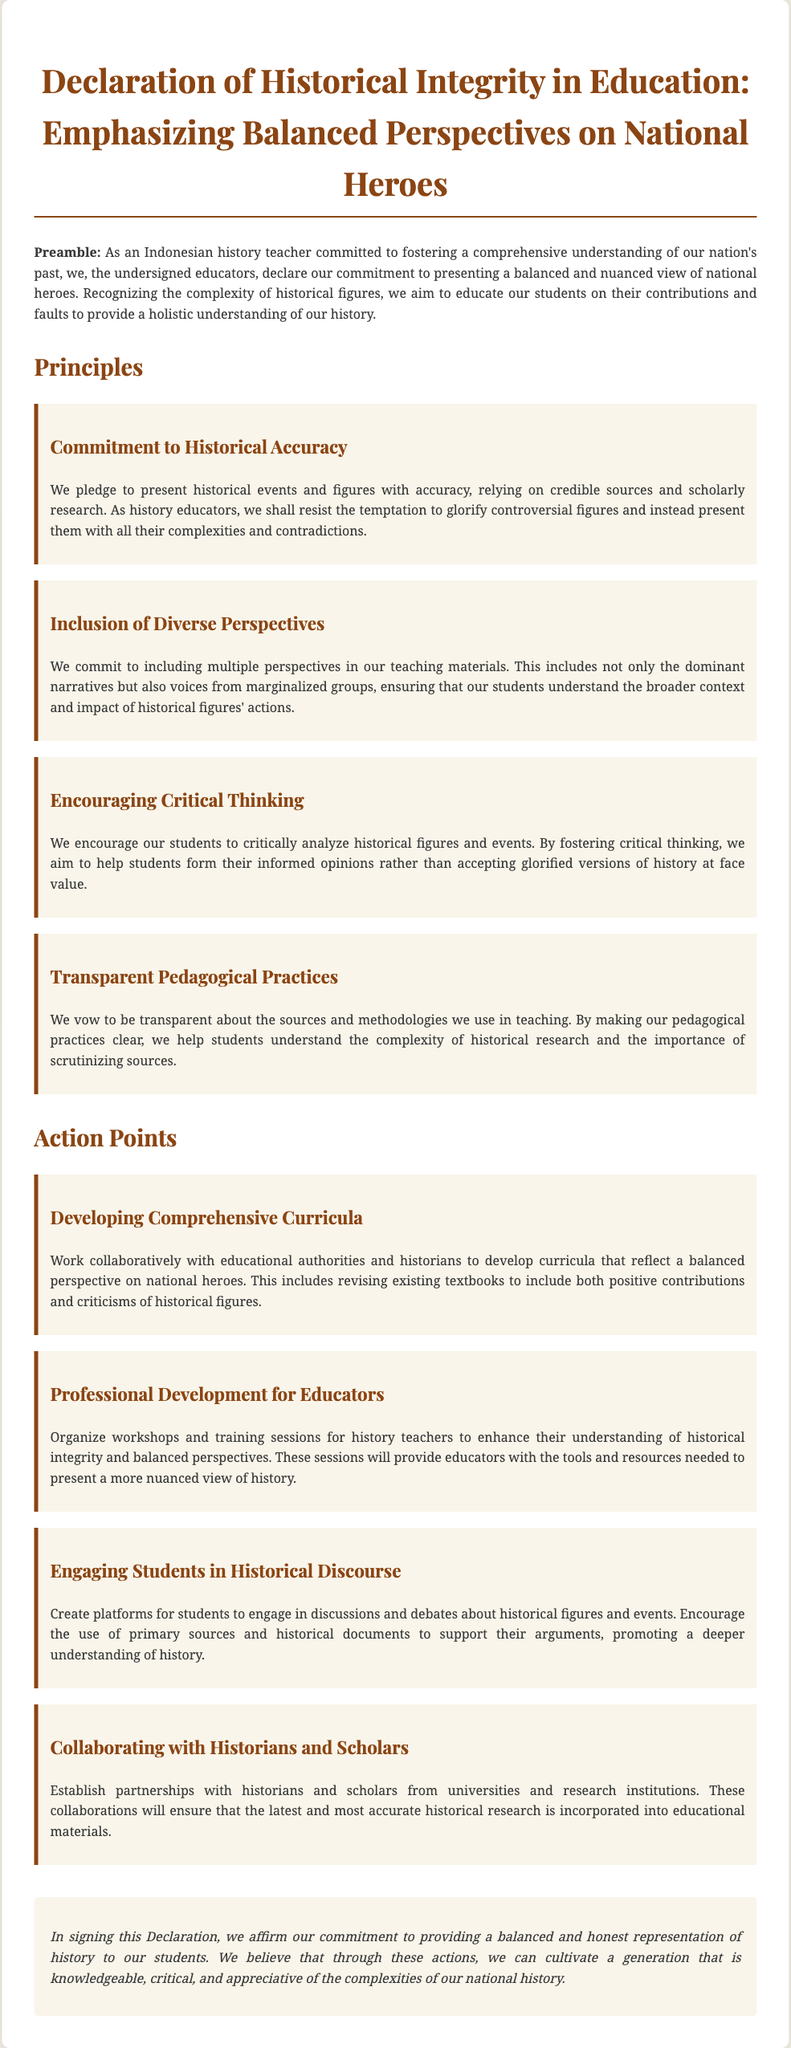What is the title of the document? The title is prominently displayed at the top of the document and states the focus of the declaration.
Answer: Declaration of Historical Integrity in Education: Emphasizing Balanced Perspectives on National Heroes Who are the primary signers of the declaration? The document mentions "the undersigned educators," indicating that it is a collective statement by teachers.
Answer: educators What is the first principle outlined in the document? The first principle is clearly listed under the Principles section, focusing on the importance of accuracy in history.
Answer: Commitment to Historical Accuracy How many action points are included in the declaration? The document enumerates specific actions under the Action Points section, indicating the total number of listed actions.
Answer: Four What does the principle of "Encouraging Critical Thinking" advocate? This principle emphasizes the importance of helping students form informed opinions rather than accepting glorified versions of history.
Answer: critical analysis What is the main purpose of the action point "Collaborating with Historians and Scholars"? The purpose is highlighted within the context of ensuring the inclusion of accurate historical research in education.
Answer: Incorporate accurate historical research Which educational method is promoted for engaging students according to the action points? The document states the creation of platforms for discussions and debates about historical figures and events.
Answer: discussions and debates What is the concluding statement's focus in the document? The conclusion emphasizes the commitment to balanced and honest representation of history to students.
Answer: balanced and honest representation 